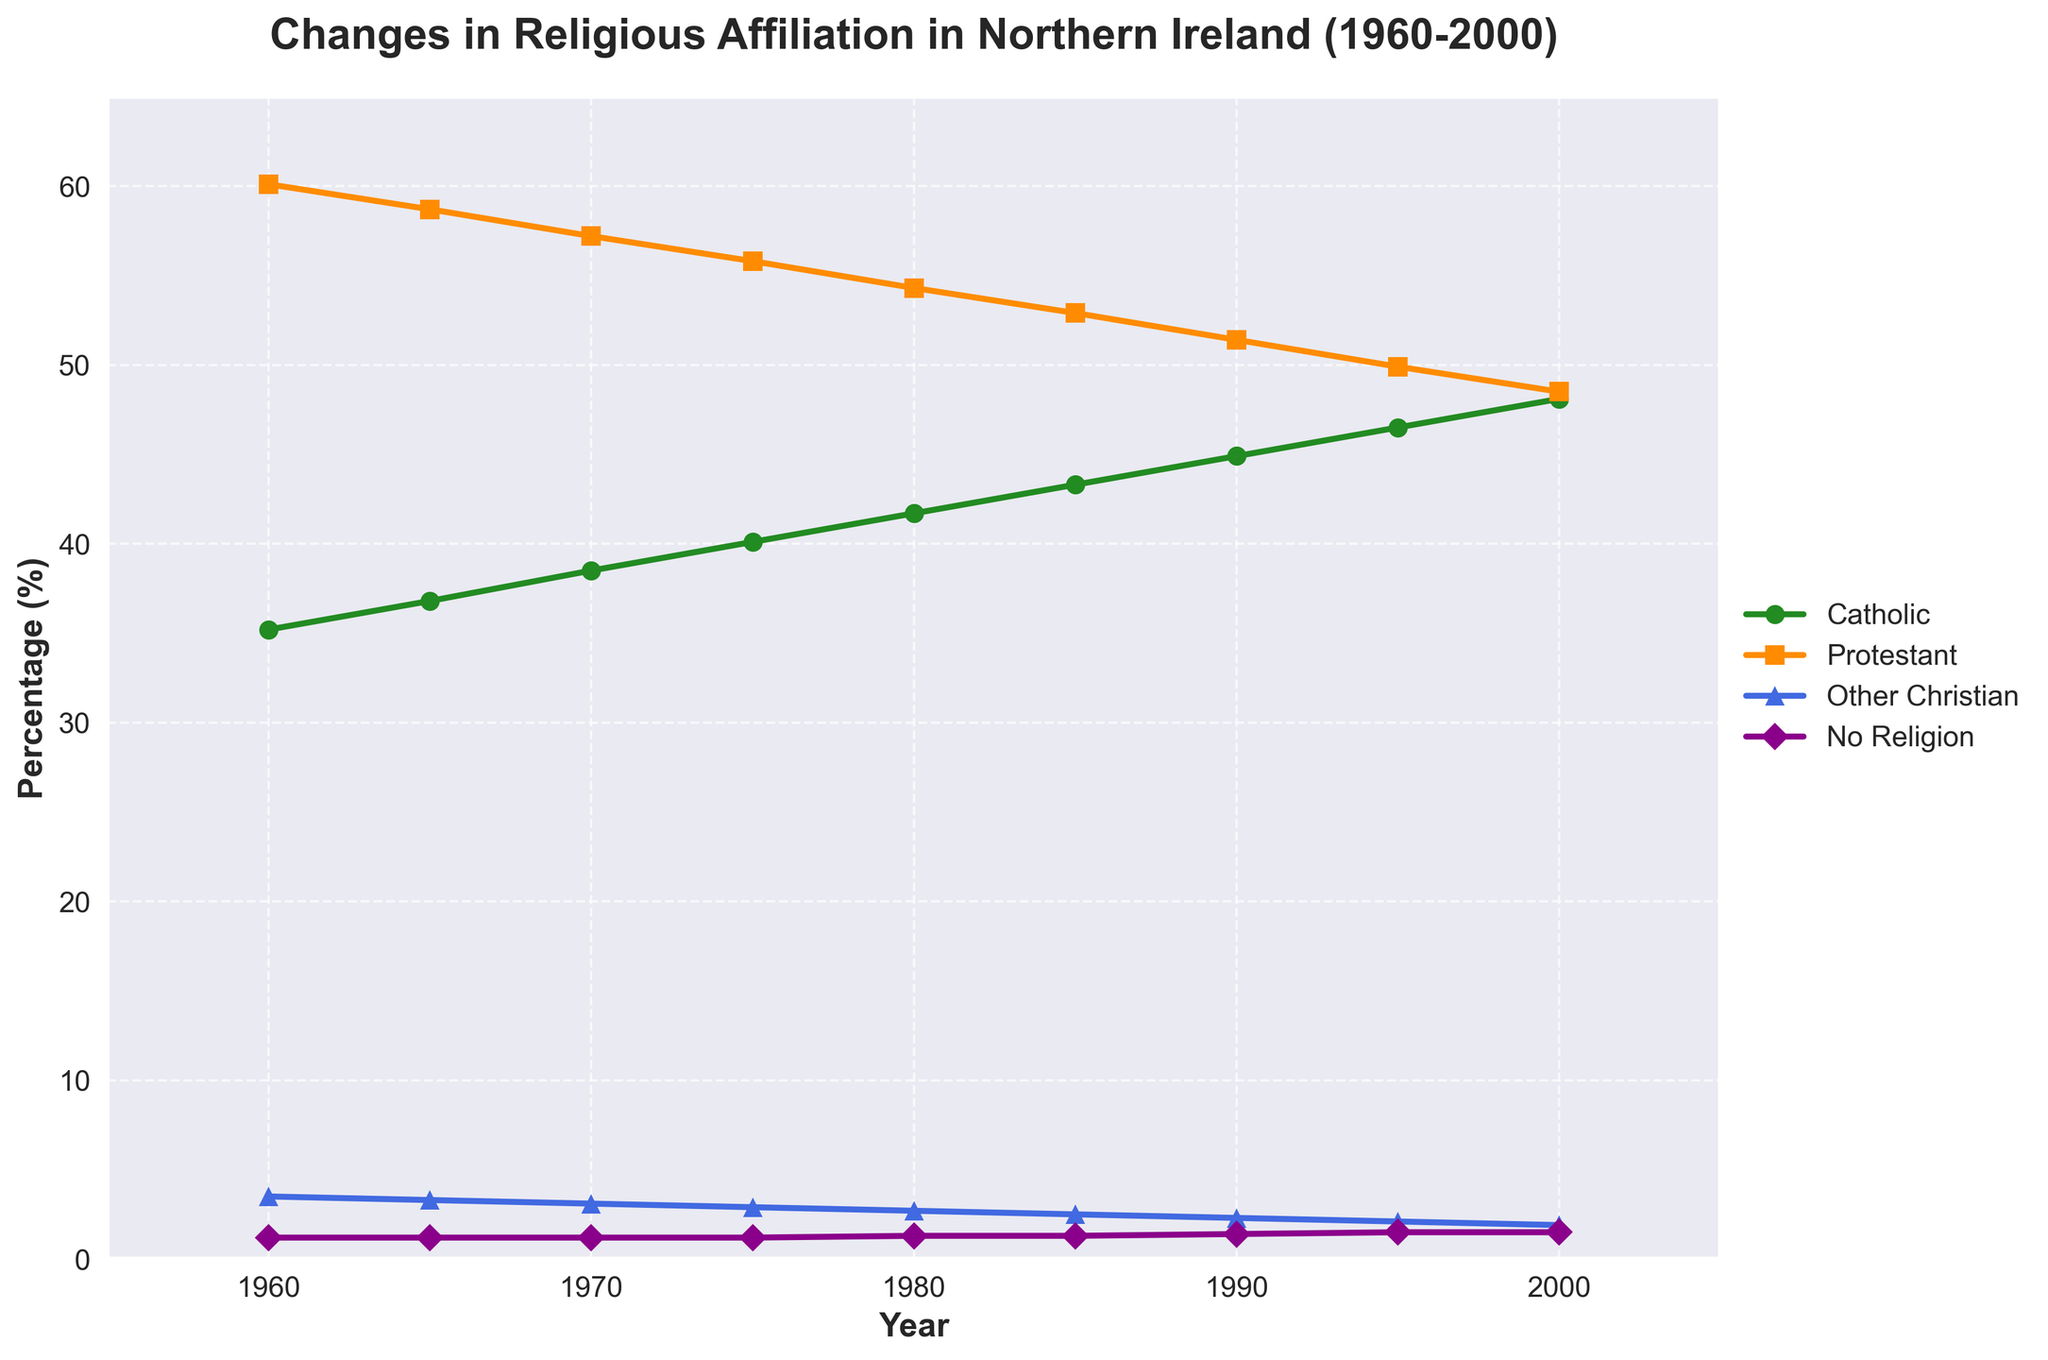What was the percentage increase in the Catholic population from 1960 to 2000? To calculate the percentage increase, subtract the 1960 value from the 2000 value and then divide by the 1960 value. Finally, multiply by 100. This gives (48.1 - 35.2) / 35.2 * 100 = 36.64%.
Answer: 36.64% In which year did the Protestant population start to be less than 50%? Look for the year in the data where the Protestant percentage drops below 50% for the first time. That year is 2000.
Answer: 2000 How many years show an increase in 'No Religion' percentage? Check the 'No Religion' column and count the years where the percentage increases compared to the previous year. These years are 1980, 1985, 1990, 1995, and 2000.
Answer: 5 years Which group had the most significant decrease in percentage points from 1960 to 2000? Calculate the decrease for each group by subtracting the 2000 value from the 1960 value. 'Protestant' had a decrease from 60.1 to 48.5, which is 11.6 percentage points, the highest decrease.
Answer: Protestant In 1980, what is the difference between the percentages of Catholic and Protestant populations? Subtract the percentage of Catholic population in 1980 from the Protestant population in 1980: 54.3 - 41.7 = 12.6%.
Answer: 12.6% Which group showed the least amount of change over the 40-year period? Compare the percentage change for each group from 1960 to 2000. 'No Religion' changed from 1.2% to 1.5%, which is the least change (only 0.3 percentage points).
Answer: No Religion What is the overall trend for the 'Other Christian' group from 1960 to 2000? Observe the data for 'Other Christian' group over the years. The percentage consistently decreases from 3.5% in 1960 to 1.9% in 2000.
Answer: Decreasing What is the average percentage of the Protestant population from 1960 to 2000? Sum the Protestant percentages from each year and divide by the number of data points: (60.1 + 58.7 + 57.2 + 55.8 + 54.3 + 52.9 + 51.4 + 49.9 + 48.5) / 9 = 54.31%.
Answer: 54.31% Which two groups' lines show the most noticeable crossing pattern? Visually inspect the plot and see where two lines cross. The 'Catholic' and 'Protestant' lines cross around the year 2000.
Answer: Catholic and Protestant From 1985 to 1990, which group saw the largest percentage decrease? Look at the differences in percentages between 1985 and 1990 for all groups. The 'Protestant' group decreased from 52.9% to 51.4%, which is a 1.5 percentage point decrease, the largest among the groups.
Answer: Protestant 